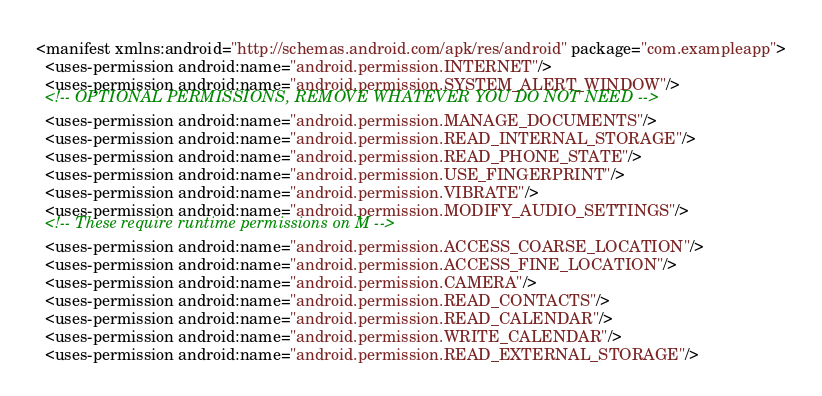<code> <loc_0><loc_0><loc_500><loc_500><_XML_><manifest xmlns:android="http://schemas.android.com/apk/res/android" package="com.exampleapp">
  <uses-permission android:name="android.permission.INTERNET"/>
  <uses-permission android:name="android.permission.SYSTEM_ALERT_WINDOW"/>
  <!-- OPTIONAL PERMISSIONS, REMOVE WHATEVER YOU DO NOT NEED -->
  <uses-permission android:name="android.permission.MANAGE_DOCUMENTS"/>
  <uses-permission android:name="android.permission.READ_INTERNAL_STORAGE"/>
  <uses-permission android:name="android.permission.READ_PHONE_STATE"/>
  <uses-permission android:name="android.permission.USE_FINGERPRINT"/>
  <uses-permission android:name="android.permission.VIBRATE"/>
  <uses-permission android:name="android.permission.MODIFY_AUDIO_SETTINGS"/>
  <!-- These require runtime permissions on M -->
  <uses-permission android:name="android.permission.ACCESS_COARSE_LOCATION"/>
  <uses-permission android:name="android.permission.ACCESS_FINE_LOCATION"/>
  <uses-permission android:name="android.permission.CAMERA"/>
  <uses-permission android:name="android.permission.READ_CONTACTS"/>
  <uses-permission android:name="android.permission.READ_CALENDAR"/>
  <uses-permission android:name="android.permission.WRITE_CALENDAR"/>
  <uses-permission android:name="android.permission.READ_EXTERNAL_STORAGE"/></code> 